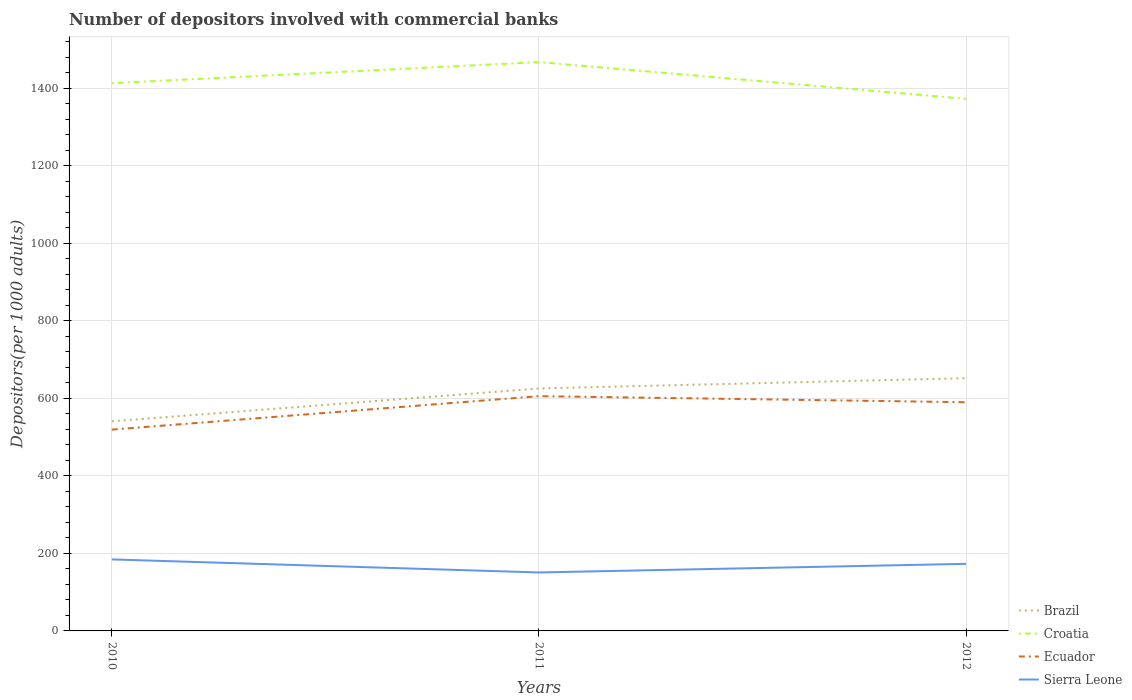Is the number of lines equal to the number of legend labels?
Ensure brevity in your answer.  Yes. Across all years, what is the maximum number of depositors involved with commercial banks in Ecuador?
Your response must be concise. 519.36. What is the total number of depositors involved with commercial banks in Ecuador in the graph?
Keep it short and to the point. 15.61. What is the difference between the highest and the second highest number of depositors involved with commercial banks in Croatia?
Provide a succinct answer. 94.79. Is the number of depositors involved with commercial banks in Croatia strictly greater than the number of depositors involved with commercial banks in Ecuador over the years?
Give a very brief answer. No. How many legend labels are there?
Give a very brief answer. 4. What is the title of the graph?
Your answer should be compact. Number of depositors involved with commercial banks. What is the label or title of the Y-axis?
Provide a short and direct response. Depositors(per 1000 adults). What is the Depositors(per 1000 adults) of Brazil in 2010?
Offer a terse response. 540.79. What is the Depositors(per 1000 adults) in Croatia in 2010?
Provide a short and direct response. 1413.08. What is the Depositors(per 1000 adults) of Ecuador in 2010?
Make the answer very short. 519.36. What is the Depositors(per 1000 adults) of Sierra Leone in 2010?
Offer a terse response. 184.46. What is the Depositors(per 1000 adults) in Brazil in 2011?
Make the answer very short. 625.53. What is the Depositors(per 1000 adults) of Croatia in 2011?
Keep it short and to the point. 1467.49. What is the Depositors(per 1000 adults) of Ecuador in 2011?
Make the answer very short. 605.63. What is the Depositors(per 1000 adults) of Sierra Leone in 2011?
Provide a succinct answer. 150.85. What is the Depositors(per 1000 adults) in Brazil in 2012?
Make the answer very short. 652.04. What is the Depositors(per 1000 adults) of Croatia in 2012?
Your answer should be compact. 1372.7. What is the Depositors(per 1000 adults) in Ecuador in 2012?
Provide a short and direct response. 590.02. What is the Depositors(per 1000 adults) of Sierra Leone in 2012?
Offer a terse response. 173.07. Across all years, what is the maximum Depositors(per 1000 adults) in Brazil?
Provide a short and direct response. 652.04. Across all years, what is the maximum Depositors(per 1000 adults) in Croatia?
Ensure brevity in your answer.  1467.49. Across all years, what is the maximum Depositors(per 1000 adults) in Ecuador?
Offer a very short reply. 605.63. Across all years, what is the maximum Depositors(per 1000 adults) of Sierra Leone?
Offer a very short reply. 184.46. Across all years, what is the minimum Depositors(per 1000 adults) of Brazil?
Ensure brevity in your answer.  540.79. Across all years, what is the minimum Depositors(per 1000 adults) of Croatia?
Offer a very short reply. 1372.7. Across all years, what is the minimum Depositors(per 1000 adults) in Ecuador?
Ensure brevity in your answer.  519.36. Across all years, what is the minimum Depositors(per 1000 adults) of Sierra Leone?
Your answer should be compact. 150.85. What is the total Depositors(per 1000 adults) in Brazil in the graph?
Give a very brief answer. 1818.36. What is the total Depositors(per 1000 adults) in Croatia in the graph?
Ensure brevity in your answer.  4253.28. What is the total Depositors(per 1000 adults) in Ecuador in the graph?
Provide a short and direct response. 1715.02. What is the total Depositors(per 1000 adults) in Sierra Leone in the graph?
Your answer should be compact. 508.38. What is the difference between the Depositors(per 1000 adults) of Brazil in 2010 and that in 2011?
Your answer should be very brief. -84.74. What is the difference between the Depositors(per 1000 adults) of Croatia in 2010 and that in 2011?
Keep it short and to the point. -54.41. What is the difference between the Depositors(per 1000 adults) in Ecuador in 2010 and that in 2011?
Provide a succinct answer. -86.27. What is the difference between the Depositors(per 1000 adults) in Sierra Leone in 2010 and that in 2011?
Your answer should be very brief. 33.62. What is the difference between the Depositors(per 1000 adults) in Brazil in 2010 and that in 2012?
Provide a short and direct response. -111.25. What is the difference between the Depositors(per 1000 adults) in Croatia in 2010 and that in 2012?
Offer a very short reply. 40.38. What is the difference between the Depositors(per 1000 adults) in Ecuador in 2010 and that in 2012?
Make the answer very short. -70.66. What is the difference between the Depositors(per 1000 adults) of Sierra Leone in 2010 and that in 2012?
Ensure brevity in your answer.  11.39. What is the difference between the Depositors(per 1000 adults) of Brazil in 2011 and that in 2012?
Offer a very short reply. -26.51. What is the difference between the Depositors(per 1000 adults) of Croatia in 2011 and that in 2012?
Your answer should be compact. 94.79. What is the difference between the Depositors(per 1000 adults) of Ecuador in 2011 and that in 2012?
Make the answer very short. 15.61. What is the difference between the Depositors(per 1000 adults) of Sierra Leone in 2011 and that in 2012?
Provide a short and direct response. -22.22. What is the difference between the Depositors(per 1000 adults) in Brazil in 2010 and the Depositors(per 1000 adults) in Croatia in 2011?
Make the answer very short. -926.7. What is the difference between the Depositors(per 1000 adults) in Brazil in 2010 and the Depositors(per 1000 adults) in Ecuador in 2011?
Your answer should be very brief. -64.84. What is the difference between the Depositors(per 1000 adults) in Brazil in 2010 and the Depositors(per 1000 adults) in Sierra Leone in 2011?
Your answer should be compact. 389.95. What is the difference between the Depositors(per 1000 adults) of Croatia in 2010 and the Depositors(per 1000 adults) of Ecuador in 2011?
Keep it short and to the point. 807.45. What is the difference between the Depositors(per 1000 adults) of Croatia in 2010 and the Depositors(per 1000 adults) of Sierra Leone in 2011?
Offer a very short reply. 1262.24. What is the difference between the Depositors(per 1000 adults) of Ecuador in 2010 and the Depositors(per 1000 adults) of Sierra Leone in 2011?
Your answer should be very brief. 368.52. What is the difference between the Depositors(per 1000 adults) of Brazil in 2010 and the Depositors(per 1000 adults) of Croatia in 2012?
Ensure brevity in your answer.  -831.91. What is the difference between the Depositors(per 1000 adults) of Brazil in 2010 and the Depositors(per 1000 adults) of Ecuador in 2012?
Offer a very short reply. -49.23. What is the difference between the Depositors(per 1000 adults) of Brazil in 2010 and the Depositors(per 1000 adults) of Sierra Leone in 2012?
Give a very brief answer. 367.72. What is the difference between the Depositors(per 1000 adults) in Croatia in 2010 and the Depositors(per 1000 adults) in Ecuador in 2012?
Your response must be concise. 823.06. What is the difference between the Depositors(per 1000 adults) of Croatia in 2010 and the Depositors(per 1000 adults) of Sierra Leone in 2012?
Your response must be concise. 1240.02. What is the difference between the Depositors(per 1000 adults) in Ecuador in 2010 and the Depositors(per 1000 adults) in Sierra Leone in 2012?
Your response must be concise. 346.29. What is the difference between the Depositors(per 1000 adults) in Brazil in 2011 and the Depositors(per 1000 adults) in Croatia in 2012?
Your response must be concise. -747.17. What is the difference between the Depositors(per 1000 adults) in Brazil in 2011 and the Depositors(per 1000 adults) in Ecuador in 2012?
Give a very brief answer. 35.51. What is the difference between the Depositors(per 1000 adults) of Brazil in 2011 and the Depositors(per 1000 adults) of Sierra Leone in 2012?
Your answer should be very brief. 452.46. What is the difference between the Depositors(per 1000 adults) of Croatia in 2011 and the Depositors(per 1000 adults) of Ecuador in 2012?
Your answer should be very brief. 877.47. What is the difference between the Depositors(per 1000 adults) of Croatia in 2011 and the Depositors(per 1000 adults) of Sierra Leone in 2012?
Your answer should be very brief. 1294.42. What is the difference between the Depositors(per 1000 adults) in Ecuador in 2011 and the Depositors(per 1000 adults) in Sierra Leone in 2012?
Offer a very short reply. 432.56. What is the average Depositors(per 1000 adults) in Brazil per year?
Provide a short and direct response. 606.12. What is the average Depositors(per 1000 adults) in Croatia per year?
Offer a terse response. 1417.76. What is the average Depositors(per 1000 adults) in Ecuador per year?
Your response must be concise. 571.67. What is the average Depositors(per 1000 adults) in Sierra Leone per year?
Your answer should be compact. 169.46. In the year 2010, what is the difference between the Depositors(per 1000 adults) in Brazil and Depositors(per 1000 adults) in Croatia?
Offer a very short reply. -872.29. In the year 2010, what is the difference between the Depositors(per 1000 adults) of Brazil and Depositors(per 1000 adults) of Ecuador?
Give a very brief answer. 21.43. In the year 2010, what is the difference between the Depositors(per 1000 adults) in Brazil and Depositors(per 1000 adults) in Sierra Leone?
Your response must be concise. 356.33. In the year 2010, what is the difference between the Depositors(per 1000 adults) in Croatia and Depositors(per 1000 adults) in Ecuador?
Provide a short and direct response. 893.72. In the year 2010, what is the difference between the Depositors(per 1000 adults) of Croatia and Depositors(per 1000 adults) of Sierra Leone?
Give a very brief answer. 1228.62. In the year 2010, what is the difference between the Depositors(per 1000 adults) in Ecuador and Depositors(per 1000 adults) in Sierra Leone?
Provide a succinct answer. 334.9. In the year 2011, what is the difference between the Depositors(per 1000 adults) of Brazil and Depositors(per 1000 adults) of Croatia?
Offer a terse response. -841.96. In the year 2011, what is the difference between the Depositors(per 1000 adults) in Brazil and Depositors(per 1000 adults) in Ecuador?
Keep it short and to the point. 19.9. In the year 2011, what is the difference between the Depositors(per 1000 adults) in Brazil and Depositors(per 1000 adults) in Sierra Leone?
Make the answer very short. 474.68. In the year 2011, what is the difference between the Depositors(per 1000 adults) of Croatia and Depositors(per 1000 adults) of Ecuador?
Offer a terse response. 861.86. In the year 2011, what is the difference between the Depositors(per 1000 adults) of Croatia and Depositors(per 1000 adults) of Sierra Leone?
Provide a succinct answer. 1316.65. In the year 2011, what is the difference between the Depositors(per 1000 adults) of Ecuador and Depositors(per 1000 adults) of Sierra Leone?
Provide a short and direct response. 454.79. In the year 2012, what is the difference between the Depositors(per 1000 adults) of Brazil and Depositors(per 1000 adults) of Croatia?
Provide a short and direct response. -720.66. In the year 2012, what is the difference between the Depositors(per 1000 adults) in Brazil and Depositors(per 1000 adults) in Ecuador?
Provide a short and direct response. 62.02. In the year 2012, what is the difference between the Depositors(per 1000 adults) of Brazil and Depositors(per 1000 adults) of Sierra Leone?
Your answer should be compact. 478.97. In the year 2012, what is the difference between the Depositors(per 1000 adults) in Croatia and Depositors(per 1000 adults) in Ecuador?
Your response must be concise. 782.68. In the year 2012, what is the difference between the Depositors(per 1000 adults) in Croatia and Depositors(per 1000 adults) in Sierra Leone?
Ensure brevity in your answer.  1199.63. In the year 2012, what is the difference between the Depositors(per 1000 adults) in Ecuador and Depositors(per 1000 adults) in Sierra Leone?
Your response must be concise. 416.95. What is the ratio of the Depositors(per 1000 adults) in Brazil in 2010 to that in 2011?
Offer a very short reply. 0.86. What is the ratio of the Depositors(per 1000 adults) in Croatia in 2010 to that in 2011?
Keep it short and to the point. 0.96. What is the ratio of the Depositors(per 1000 adults) of Ecuador in 2010 to that in 2011?
Ensure brevity in your answer.  0.86. What is the ratio of the Depositors(per 1000 adults) in Sierra Leone in 2010 to that in 2011?
Provide a short and direct response. 1.22. What is the ratio of the Depositors(per 1000 adults) in Brazil in 2010 to that in 2012?
Your answer should be very brief. 0.83. What is the ratio of the Depositors(per 1000 adults) of Croatia in 2010 to that in 2012?
Make the answer very short. 1.03. What is the ratio of the Depositors(per 1000 adults) in Ecuador in 2010 to that in 2012?
Your response must be concise. 0.88. What is the ratio of the Depositors(per 1000 adults) of Sierra Leone in 2010 to that in 2012?
Give a very brief answer. 1.07. What is the ratio of the Depositors(per 1000 adults) of Brazil in 2011 to that in 2012?
Provide a short and direct response. 0.96. What is the ratio of the Depositors(per 1000 adults) in Croatia in 2011 to that in 2012?
Offer a terse response. 1.07. What is the ratio of the Depositors(per 1000 adults) in Ecuador in 2011 to that in 2012?
Provide a short and direct response. 1.03. What is the ratio of the Depositors(per 1000 adults) of Sierra Leone in 2011 to that in 2012?
Your answer should be compact. 0.87. What is the difference between the highest and the second highest Depositors(per 1000 adults) of Brazil?
Keep it short and to the point. 26.51. What is the difference between the highest and the second highest Depositors(per 1000 adults) in Croatia?
Ensure brevity in your answer.  54.41. What is the difference between the highest and the second highest Depositors(per 1000 adults) in Ecuador?
Your answer should be very brief. 15.61. What is the difference between the highest and the second highest Depositors(per 1000 adults) in Sierra Leone?
Offer a terse response. 11.39. What is the difference between the highest and the lowest Depositors(per 1000 adults) in Brazil?
Give a very brief answer. 111.25. What is the difference between the highest and the lowest Depositors(per 1000 adults) of Croatia?
Offer a terse response. 94.79. What is the difference between the highest and the lowest Depositors(per 1000 adults) of Ecuador?
Make the answer very short. 86.27. What is the difference between the highest and the lowest Depositors(per 1000 adults) in Sierra Leone?
Your response must be concise. 33.62. 